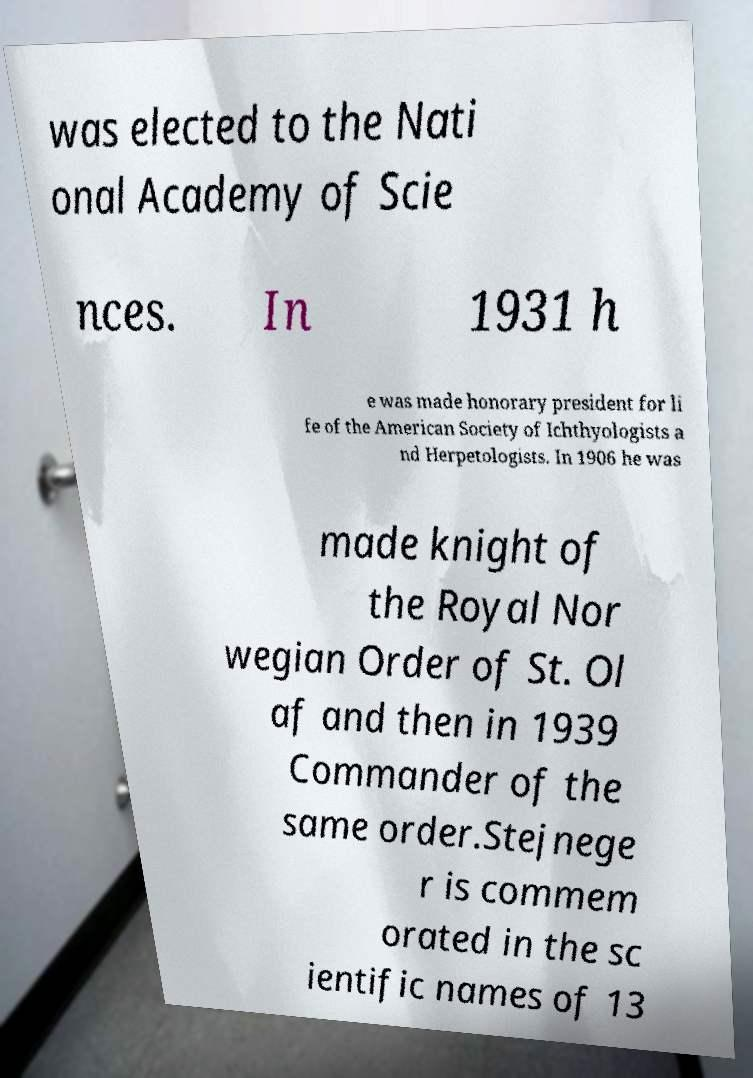Please identify and transcribe the text found in this image. was elected to the Nati onal Academy of Scie nces. In 1931 h e was made honorary president for li fe of the American Society of Ichthyologists a nd Herpetologists. In 1906 he was made knight of the Royal Nor wegian Order of St. Ol af and then in 1939 Commander of the same order.Stejnege r is commem orated in the sc ientific names of 13 